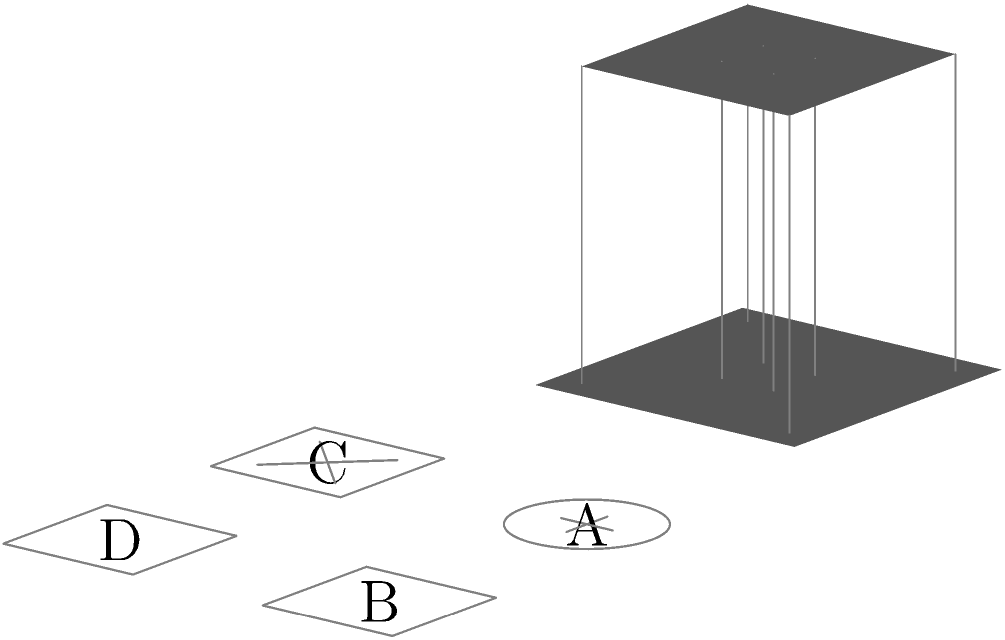As part of our app development process for innovative architectural visualization, we need to accurately represent complex 3D structures from various perspectives. Given the 3D structure shown above, which option (A, B, C, or D) correctly represents its top-down view? To determine the correct top-down view, let's analyze the 3D structure step-by-step:

1. The structure consists of a square base with four outer pillars at the corners and a central pillar.
2. There's a square top platform that's smaller than the base, supported by the pillars.
3. From a top-down perspective, we would see:
   a) The outer square shape of the top platform
   b) The inner square shape of the central pillar

4. Examining the options:
   A: Shows a circle with a cross, which doesn't match our structure.
   B: Shows a simple square, which partially matches but lacks detail.
   C: Shows a square with diagonal lines, which doesn't represent our structure.
   D: Shows a square with a smaller square inside, which correctly represents the top platform and central pillar.

5. Option D accurately depicts the top-down view of our structure, showing both the outer square (top platform) and the inner square (central pillar).

This type of spatial reasoning is crucial for developing 3D visualization apps, as it helps in accurately representing complex structures from different viewpoints.
Answer: D 